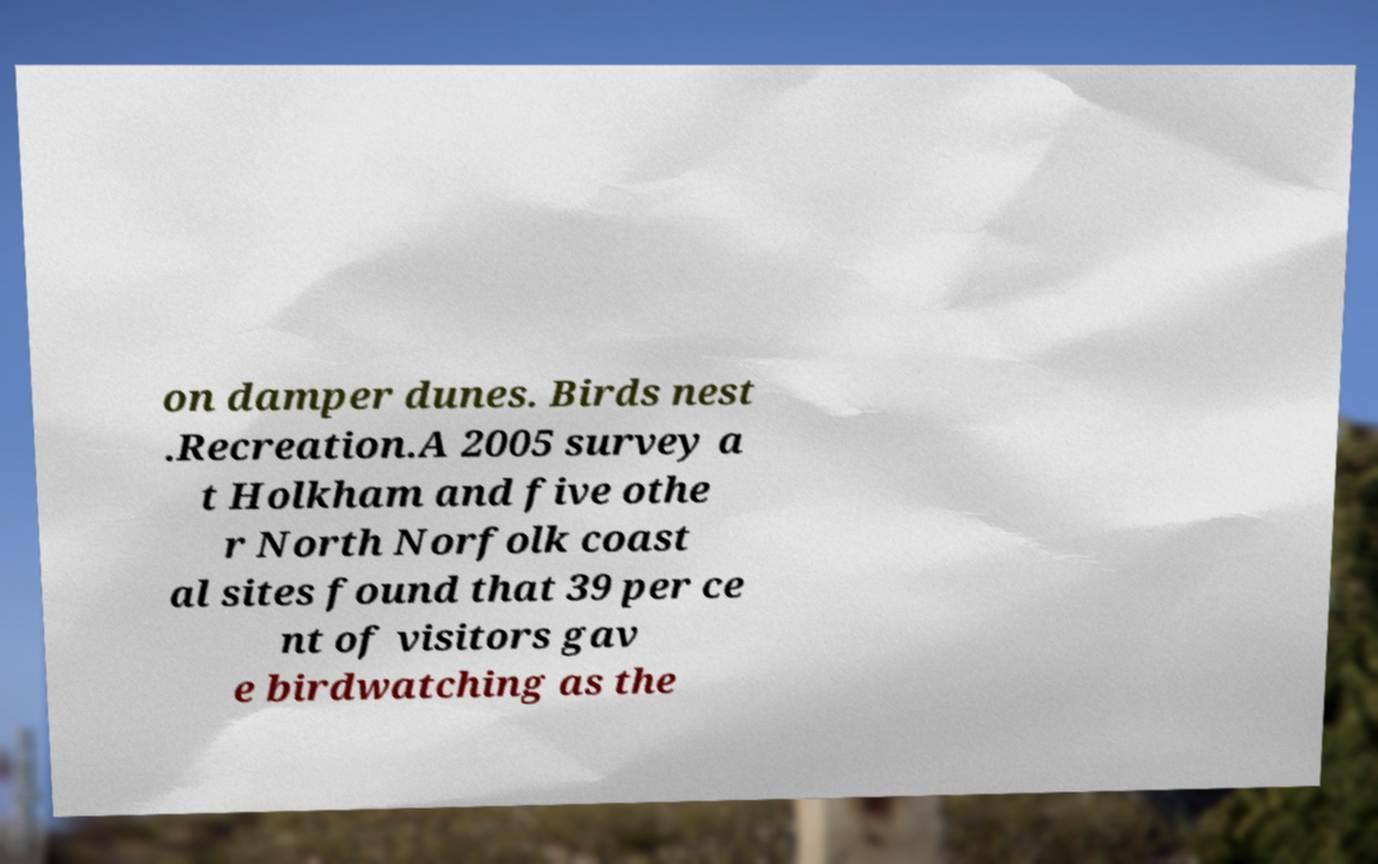For documentation purposes, I need the text within this image transcribed. Could you provide that? on damper dunes. Birds nest .Recreation.A 2005 survey a t Holkham and five othe r North Norfolk coast al sites found that 39 per ce nt of visitors gav e birdwatching as the 